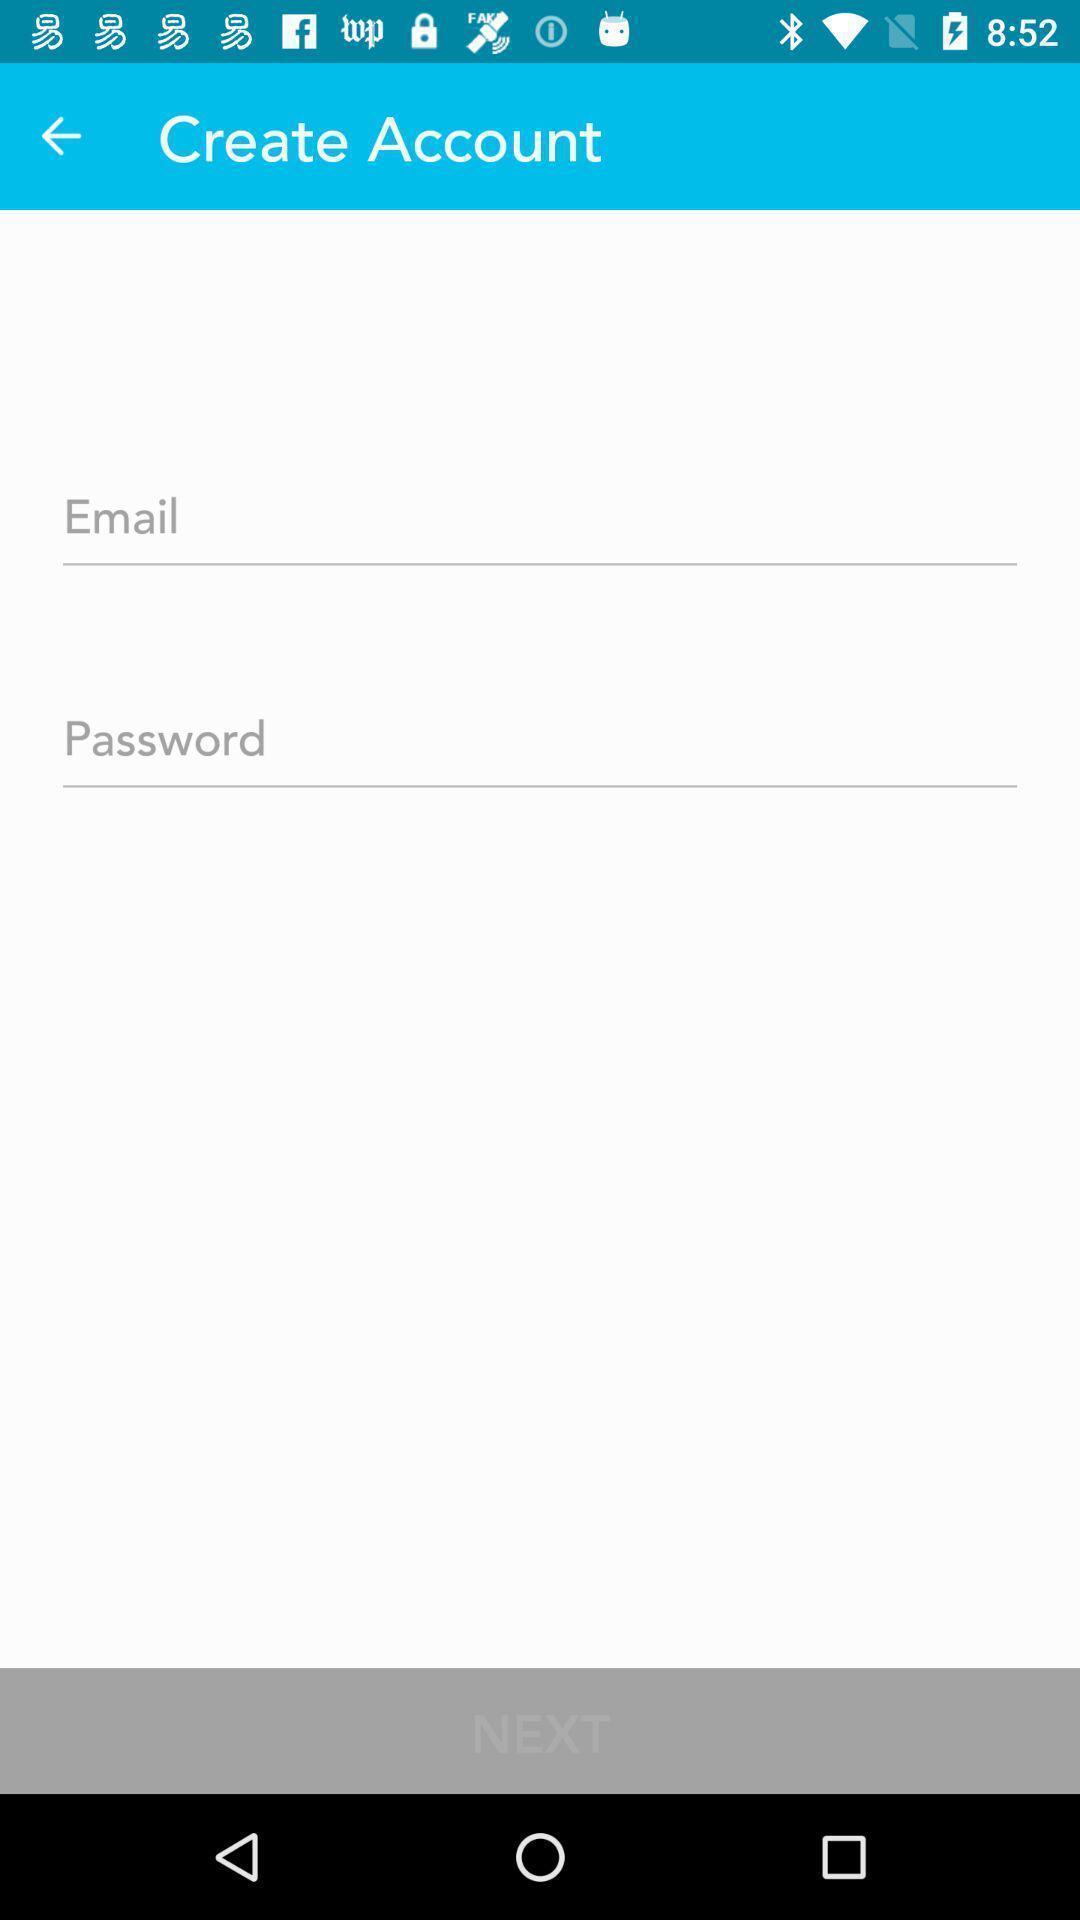Provide a description of this screenshot. Page showing create account for accessing an account. 